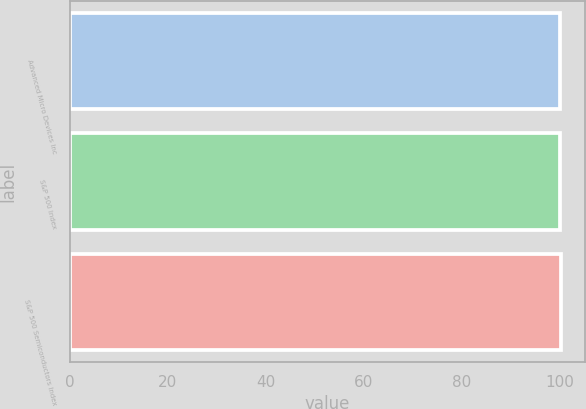Convert chart. <chart><loc_0><loc_0><loc_500><loc_500><bar_chart><fcel>Advanced Micro Devices Inc<fcel>S&P 500 Index<fcel>S&P 500 Semiconductors Index<nl><fcel>100<fcel>100.1<fcel>100.2<nl></chart> 